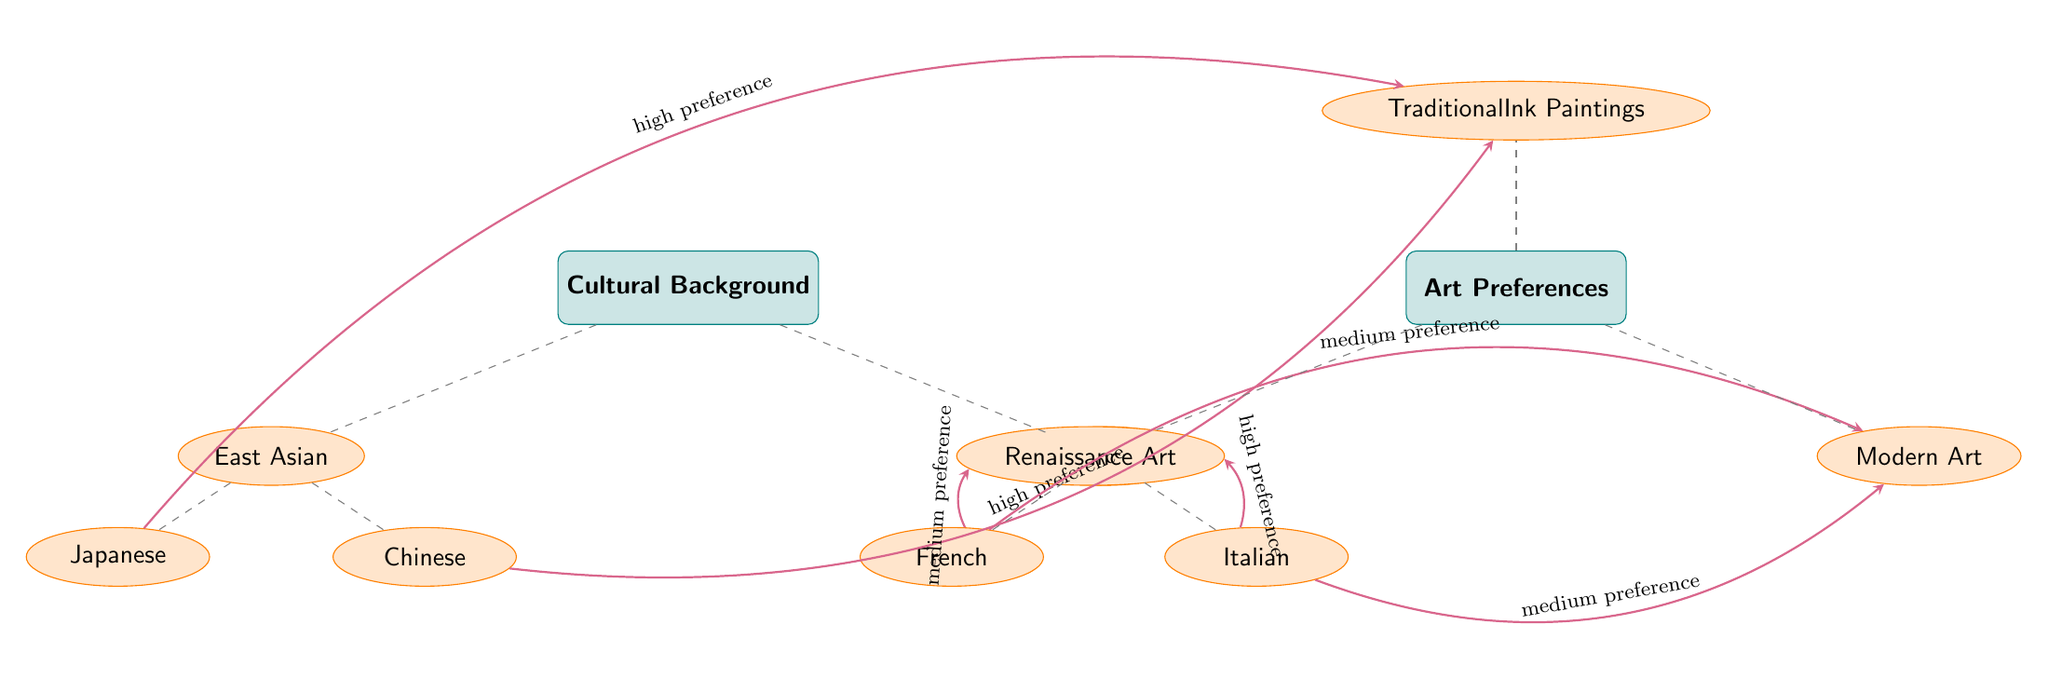What are the two main categories represented in the diagram? The diagram has two main categories which are "Cultural Background" and "Art Preferences." These categories are represented by distinct rectangle nodes at the top of the diagram.
Answer: Cultural Background, Art Preferences How many subcategories are listed under Cultural Background? Under the main category "Cultural Background," there are two subcategories: "East Asian" and "European." Therefore, the total number of subcategories is two.
Answer: 2 Which art preference has a high preference connection from both Japanese and Chinese subcategories? Both the "Japanese" and "Chinese" subcategories from "East Asian" connect to "Traditional Ink Paintings" with a high preference indicating a strong inclination towards this art form.
Answer: Traditional Ink Paintings What preference do French individuals have toward Renaissance art? The connection between the "French" subcategory and "Renaissance Art" indicates a medium preference, suggesting that while there is some appreciation, it is not as strong as high preference connections.
Answer: Medium preference What is the connection strength of the Italian subcategory toward Modern Art? The "Italian" subcategory connects to "Modern Art" with a medium preference. This indicates that Italians have a moderate appreciation for Modern Art, although it is lower than the high preferences noted for other connections.
Answer: Medium preference Which cultural background shows a high preference for Traditional Ink Paintings? The "East Asian" cultural background is indicated to have a strong connection with "Traditional Ink Paintings," particularly from the Japanese and Chinese subcategories, both of which are highlighted under this link.
Answer: East Asian How many edges connect the European subcategory nodes to the Art Preferences? The European subcategory consists of two nodes, "French" and "Italian," both of which independently connect to two "Art Preference" categories. This results in a total of four edges connecting these two subcategories to "Art Preferences."
Answer: 4 Which art preference has a high preference from the Italian subcategory? Among the connections of the "Italian" subcategory, there is a high preference link to "Renaissance Art," indicating a strong inclination of Italians toward this specific type of art.
Answer: Renaissance Art 